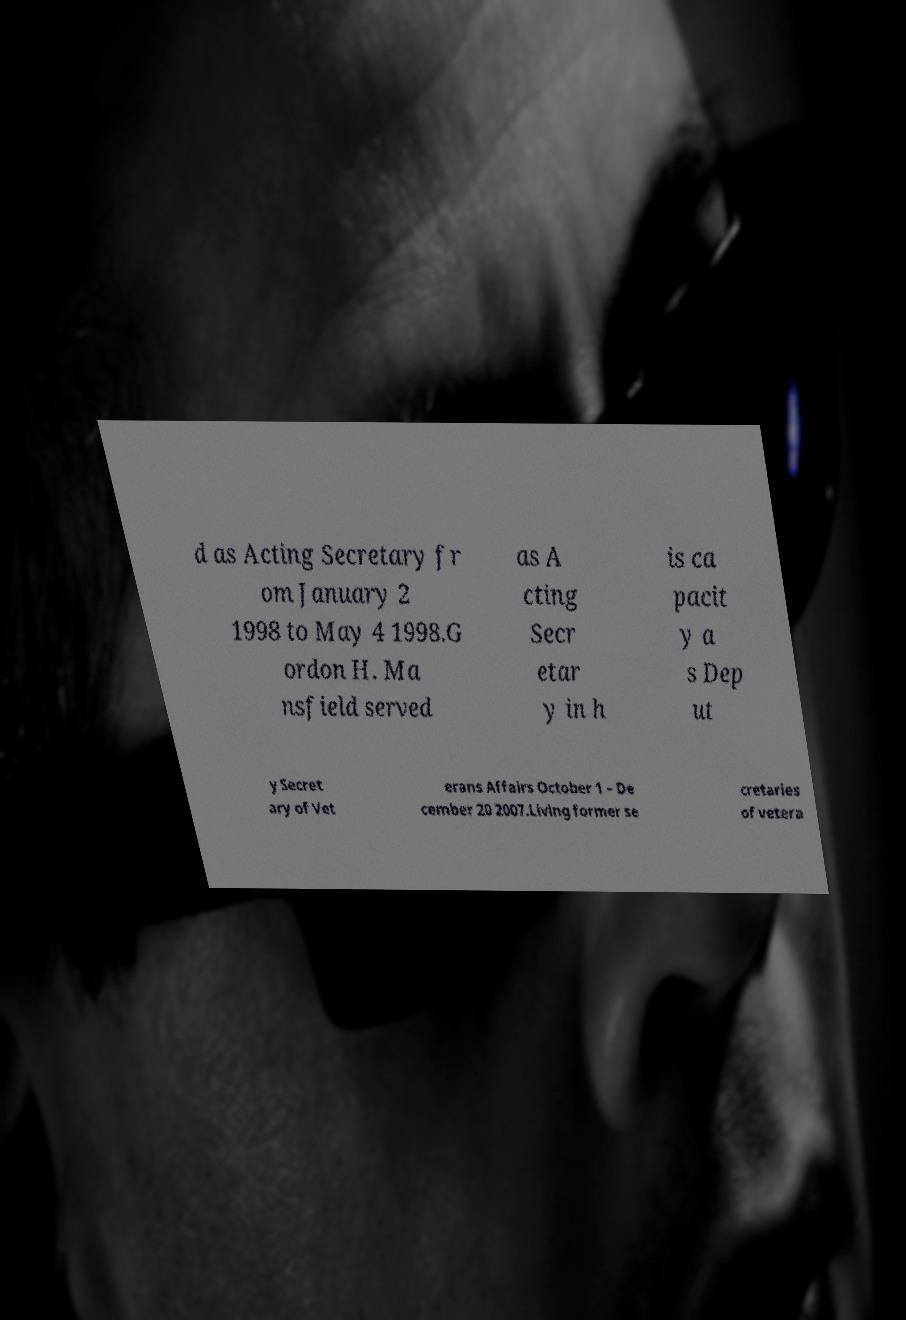Please read and relay the text visible in this image. What does it say? d as Acting Secretary fr om January 2 1998 to May 4 1998.G ordon H. Ma nsfield served as A cting Secr etar y in h is ca pacit y a s Dep ut y Secret ary of Vet erans Affairs October 1 – De cember 20 2007.Living former se cretaries of vetera 